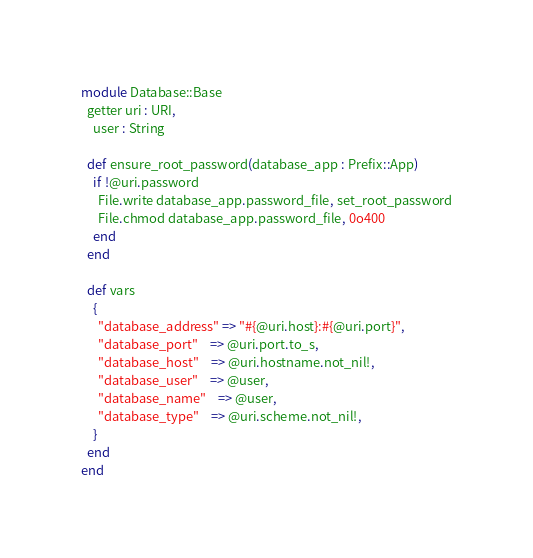<code> <loc_0><loc_0><loc_500><loc_500><_Crystal_>module Database::Base
  getter uri : URI,
    user : String

  def ensure_root_password(database_app : Prefix::App)
    if !@uri.password
      File.write database_app.password_file, set_root_password
      File.chmod database_app.password_file, 0o400
    end
  end

  def vars
    {
      "database_address" => "#{@uri.host}:#{@uri.port}",
      "database_port"    => @uri.port.to_s,
      "database_host"    => @uri.hostname.not_nil!,
      "database_user"    => @user,
      "database_name"    => @user,
      "database_type"    => @uri.scheme.not_nil!,
    }
  end
end
</code> 